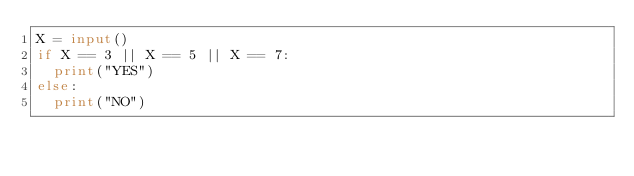<code> <loc_0><loc_0><loc_500><loc_500><_Python_>X = input()
if X == 3 || X == 5 || X == 7:
  print("YES")
else:
  print("NO")</code> 